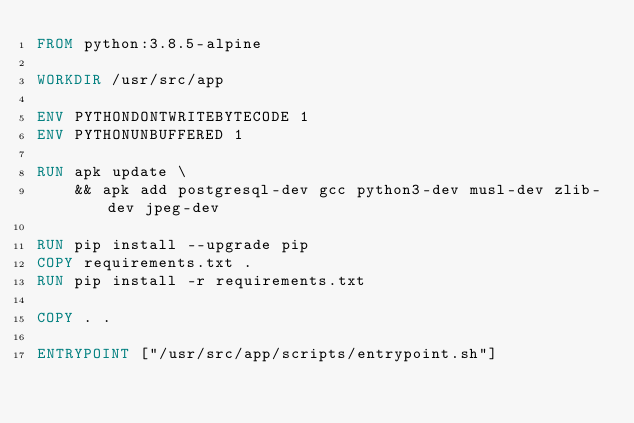<code> <loc_0><loc_0><loc_500><loc_500><_Dockerfile_>FROM python:3.8.5-alpine 

WORKDIR /usr/src/app

ENV PYTHONDONTWRITEBYTECODE 1
ENV PYTHONUNBUFFERED 1

RUN apk update \
    && apk add postgresql-dev gcc python3-dev musl-dev zlib-dev jpeg-dev

RUN pip install --upgrade pip
COPY requirements.txt .
RUN pip install -r requirements.txt

COPY . .

ENTRYPOINT ["/usr/src/app/scripts/entrypoint.sh"]</code> 